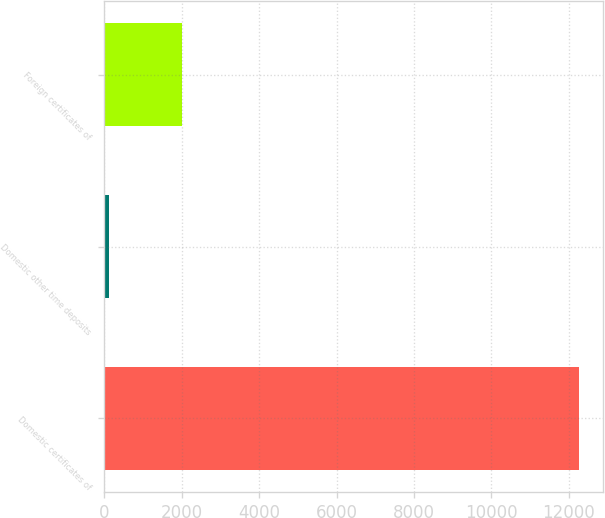Convert chart to OTSL. <chart><loc_0><loc_0><loc_500><loc_500><bar_chart><fcel>Domestic certificates of<fcel>Domestic other time deposits<fcel>Foreign certificates of<nl><fcel>12271<fcel>113<fcel>1994<nl></chart> 